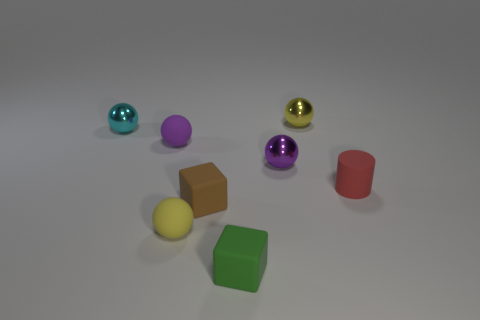There is a rubber cylinder that is the same size as the cyan thing; what color is it?
Keep it short and to the point. Red. There is a small red rubber cylinder; how many tiny yellow things are behind it?
Provide a succinct answer. 1. Is there a yellow object?
Provide a short and direct response. Yes. There is a brown thing in front of the yellow ball that is behind the purple object to the right of the tiny brown matte thing; how big is it?
Offer a very short reply. Small. What number of other objects are the same size as the cyan object?
Ensure brevity in your answer.  7. What size is the purple matte object left of the brown object?
Offer a very short reply. Small. Does the yellow ball in front of the cyan metal ball have the same material as the tiny green cube?
Provide a succinct answer. Yes. How many things are both to the right of the green rubber cube and in front of the small brown cube?
Give a very brief answer. 0. What is the size of the yellow sphere that is behind the yellow ball in front of the tiny red cylinder?
Make the answer very short. Small. Is there anything else that has the same material as the green thing?
Keep it short and to the point. Yes. 